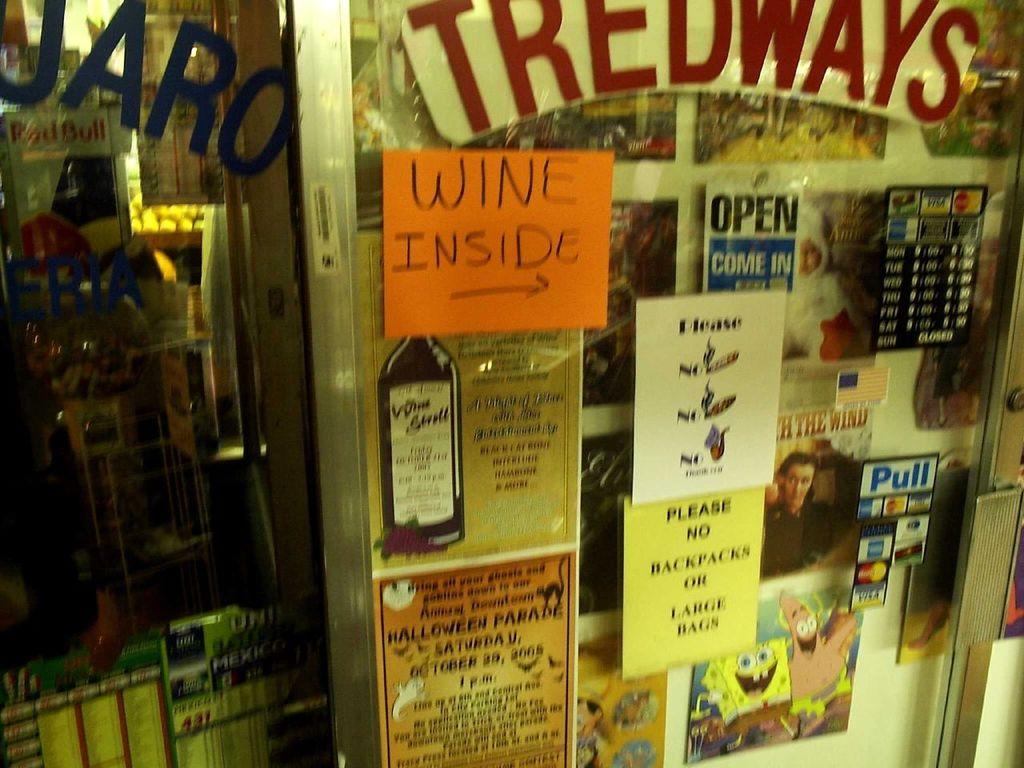What does it say is inside?
Your response must be concise. Wine. What is the top red sign?
Your response must be concise. Tredways. 